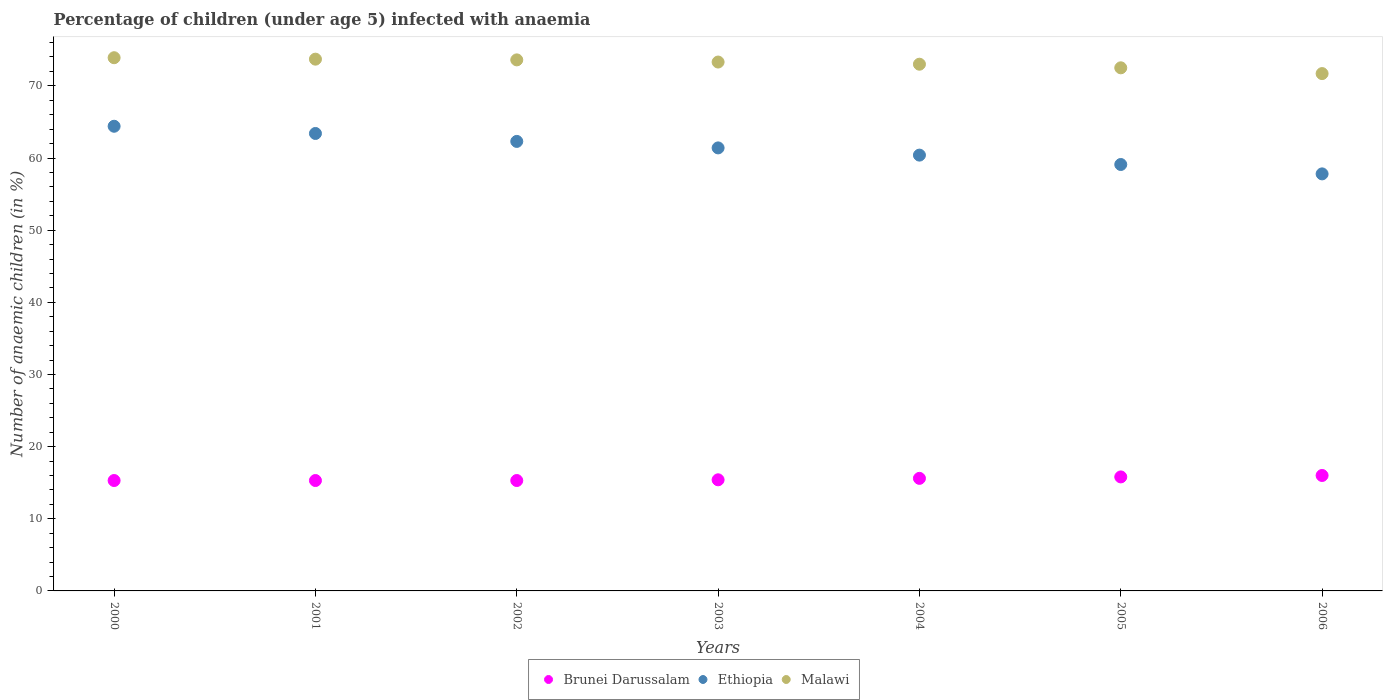What is the percentage of children infected with anaemia in in Malawi in 2003?
Offer a terse response. 73.3. Across all years, what is the maximum percentage of children infected with anaemia in in Ethiopia?
Provide a succinct answer. 64.4. Across all years, what is the minimum percentage of children infected with anaemia in in Malawi?
Your answer should be compact. 71.7. What is the total percentage of children infected with anaemia in in Brunei Darussalam in the graph?
Your answer should be compact. 108.7. What is the difference between the percentage of children infected with anaemia in in Brunei Darussalam in 2001 and that in 2005?
Offer a terse response. -0.5. What is the difference between the percentage of children infected with anaemia in in Ethiopia in 2002 and the percentage of children infected with anaemia in in Malawi in 2005?
Ensure brevity in your answer.  -10.2. What is the average percentage of children infected with anaemia in in Ethiopia per year?
Offer a very short reply. 61.26. In the year 2005, what is the difference between the percentage of children infected with anaemia in in Malawi and percentage of children infected with anaemia in in Ethiopia?
Make the answer very short. 13.4. In how many years, is the percentage of children infected with anaemia in in Ethiopia greater than 66 %?
Provide a succinct answer. 0. What is the ratio of the percentage of children infected with anaemia in in Brunei Darussalam in 2005 to that in 2006?
Your response must be concise. 0.99. Is the percentage of children infected with anaemia in in Ethiopia in 2002 less than that in 2004?
Your answer should be compact. No. What is the difference between the highest and the second highest percentage of children infected with anaemia in in Brunei Darussalam?
Your answer should be compact. 0.2. What is the difference between the highest and the lowest percentage of children infected with anaemia in in Malawi?
Ensure brevity in your answer.  2.2. In how many years, is the percentage of children infected with anaemia in in Brunei Darussalam greater than the average percentage of children infected with anaemia in in Brunei Darussalam taken over all years?
Keep it short and to the point. 3. Is the sum of the percentage of children infected with anaemia in in Malawi in 2003 and 2005 greater than the maximum percentage of children infected with anaemia in in Brunei Darussalam across all years?
Provide a succinct answer. Yes. What is the difference between two consecutive major ticks on the Y-axis?
Provide a succinct answer. 10. Does the graph contain grids?
Offer a very short reply. No. How many legend labels are there?
Make the answer very short. 3. What is the title of the graph?
Give a very brief answer. Percentage of children (under age 5) infected with anaemia. Does "Thailand" appear as one of the legend labels in the graph?
Offer a terse response. No. What is the label or title of the Y-axis?
Offer a terse response. Number of anaemic children (in %). What is the Number of anaemic children (in %) of Brunei Darussalam in 2000?
Ensure brevity in your answer.  15.3. What is the Number of anaemic children (in %) of Ethiopia in 2000?
Ensure brevity in your answer.  64.4. What is the Number of anaemic children (in %) of Malawi in 2000?
Your response must be concise. 73.9. What is the Number of anaemic children (in %) in Ethiopia in 2001?
Your answer should be very brief. 63.4. What is the Number of anaemic children (in %) of Malawi in 2001?
Offer a very short reply. 73.7. What is the Number of anaemic children (in %) of Ethiopia in 2002?
Offer a very short reply. 62.3. What is the Number of anaemic children (in %) of Malawi in 2002?
Keep it short and to the point. 73.6. What is the Number of anaemic children (in %) in Brunei Darussalam in 2003?
Provide a succinct answer. 15.4. What is the Number of anaemic children (in %) in Ethiopia in 2003?
Make the answer very short. 61.4. What is the Number of anaemic children (in %) of Malawi in 2003?
Your answer should be very brief. 73.3. What is the Number of anaemic children (in %) in Ethiopia in 2004?
Offer a terse response. 60.4. What is the Number of anaemic children (in %) of Ethiopia in 2005?
Keep it short and to the point. 59.1. What is the Number of anaemic children (in %) of Malawi in 2005?
Your answer should be compact. 72.5. What is the Number of anaemic children (in %) of Brunei Darussalam in 2006?
Your answer should be very brief. 16. What is the Number of anaemic children (in %) of Ethiopia in 2006?
Provide a succinct answer. 57.8. What is the Number of anaemic children (in %) of Malawi in 2006?
Provide a short and direct response. 71.7. Across all years, what is the maximum Number of anaemic children (in %) in Brunei Darussalam?
Keep it short and to the point. 16. Across all years, what is the maximum Number of anaemic children (in %) in Ethiopia?
Keep it short and to the point. 64.4. Across all years, what is the maximum Number of anaemic children (in %) of Malawi?
Keep it short and to the point. 73.9. Across all years, what is the minimum Number of anaemic children (in %) in Ethiopia?
Provide a short and direct response. 57.8. Across all years, what is the minimum Number of anaemic children (in %) of Malawi?
Keep it short and to the point. 71.7. What is the total Number of anaemic children (in %) of Brunei Darussalam in the graph?
Keep it short and to the point. 108.7. What is the total Number of anaemic children (in %) of Ethiopia in the graph?
Offer a terse response. 428.8. What is the total Number of anaemic children (in %) in Malawi in the graph?
Keep it short and to the point. 511.7. What is the difference between the Number of anaemic children (in %) in Ethiopia in 2000 and that in 2001?
Give a very brief answer. 1. What is the difference between the Number of anaemic children (in %) of Malawi in 2000 and that in 2002?
Your response must be concise. 0.3. What is the difference between the Number of anaemic children (in %) in Brunei Darussalam in 2000 and that in 2003?
Make the answer very short. -0.1. What is the difference between the Number of anaemic children (in %) of Malawi in 2000 and that in 2003?
Your answer should be compact. 0.6. What is the difference between the Number of anaemic children (in %) in Brunei Darussalam in 2000 and that in 2004?
Offer a terse response. -0.3. What is the difference between the Number of anaemic children (in %) in Ethiopia in 2000 and that in 2004?
Your answer should be very brief. 4. What is the difference between the Number of anaemic children (in %) of Malawi in 2000 and that in 2004?
Offer a very short reply. 0.9. What is the difference between the Number of anaemic children (in %) in Brunei Darussalam in 2000 and that in 2005?
Ensure brevity in your answer.  -0.5. What is the difference between the Number of anaemic children (in %) in Malawi in 2000 and that in 2005?
Provide a succinct answer. 1.4. What is the difference between the Number of anaemic children (in %) of Brunei Darussalam in 2000 and that in 2006?
Provide a short and direct response. -0.7. What is the difference between the Number of anaemic children (in %) of Ethiopia in 2000 and that in 2006?
Your answer should be compact. 6.6. What is the difference between the Number of anaemic children (in %) in Malawi in 2000 and that in 2006?
Keep it short and to the point. 2.2. What is the difference between the Number of anaemic children (in %) of Brunei Darussalam in 2001 and that in 2002?
Make the answer very short. 0. What is the difference between the Number of anaemic children (in %) of Brunei Darussalam in 2001 and that in 2003?
Ensure brevity in your answer.  -0.1. What is the difference between the Number of anaemic children (in %) in Malawi in 2001 and that in 2004?
Keep it short and to the point. 0.7. What is the difference between the Number of anaemic children (in %) of Brunei Darussalam in 2001 and that in 2005?
Make the answer very short. -0.5. What is the difference between the Number of anaemic children (in %) in Ethiopia in 2001 and that in 2005?
Your response must be concise. 4.3. What is the difference between the Number of anaemic children (in %) in Brunei Darussalam in 2001 and that in 2006?
Keep it short and to the point. -0.7. What is the difference between the Number of anaemic children (in %) in Ethiopia in 2001 and that in 2006?
Keep it short and to the point. 5.6. What is the difference between the Number of anaemic children (in %) of Brunei Darussalam in 2002 and that in 2003?
Make the answer very short. -0.1. What is the difference between the Number of anaemic children (in %) in Ethiopia in 2002 and that in 2003?
Give a very brief answer. 0.9. What is the difference between the Number of anaemic children (in %) in Ethiopia in 2002 and that in 2004?
Ensure brevity in your answer.  1.9. What is the difference between the Number of anaemic children (in %) of Ethiopia in 2003 and that in 2004?
Make the answer very short. 1. What is the difference between the Number of anaemic children (in %) in Malawi in 2003 and that in 2004?
Give a very brief answer. 0.3. What is the difference between the Number of anaemic children (in %) in Brunei Darussalam in 2003 and that in 2005?
Provide a succinct answer. -0.4. What is the difference between the Number of anaemic children (in %) of Ethiopia in 2003 and that in 2005?
Make the answer very short. 2.3. What is the difference between the Number of anaemic children (in %) in Brunei Darussalam in 2003 and that in 2006?
Keep it short and to the point. -0.6. What is the difference between the Number of anaemic children (in %) of Malawi in 2003 and that in 2006?
Your answer should be compact. 1.6. What is the difference between the Number of anaemic children (in %) in Ethiopia in 2004 and that in 2005?
Offer a terse response. 1.3. What is the difference between the Number of anaemic children (in %) of Malawi in 2004 and that in 2005?
Ensure brevity in your answer.  0.5. What is the difference between the Number of anaemic children (in %) of Malawi in 2004 and that in 2006?
Your response must be concise. 1.3. What is the difference between the Number of anaemic children (in %) in Brunei Darussalam in 2005 and that in 2006?
Offer a very short reply. -0.2. What is the difference between the Number of anaemic children (in %) in Ethiopia in 2005 and that in 2006?
Your response must be concise. 1.3. What is the difference between the Number of anaemic children (in %) of Malawi in 2005 and that in 2006?
Your response must be concise. 0.8. What is the difference between the Number of anaemic children (in %) of Brunei Darussalam in 2000 and the Number of anaemic children (in %) of Ethiopia in 2001?
Your answer should be very brief. -48.1. What is the difference between the Number of anaemic children (in %) of Brunei Darussalam in 2000 and the Number of anaemic children (in %) of Malawi in 2001?
Your answer should be very brief. -58.4. What is the difference between the Number of anaemic children (in %) of Brunei Darussalam in 2000 and the Number of anaemic children (in %) of Ethiopia in 2002?
Your answer should be very brief. -47. What is the difference between the Number of anaemic children (in %) of Brunei Darussalam in 2000 and the Number of anaemic children (in %) of Malawi in 2002?
Your answer should be very brief. -58.3. What is the difference between the Number of anaemic children (in %) of Ethiopia in 2000 and the Number of anaemic children (in %) of Malawi in 2002?
Your response must be concise. -9.2. What is the difference between the Number of anaemic children (in %) in Brunei Darussalam in 2000 and the Number of anaemic children (in %) in Ethiopia in 2003?
Provide a short and direct response. -46.1. What is the difference between the Number of anaemic children (in %) in Brunei Darussalam in 2000 and the Number of anaemic children (in %) in Malawi in 2003?
Your answer should be compact. -58. What is the difference between the Number of anaemic children (in %) of Ethiopia in 2000 and the Number of anaemic children (in %) of Malawi in 2003?
Provide a succinct answer. -8.9. What is the difference between the Number of anaemic children (in %) in Brunei Darussalam in 2000 and the Number of anaemic children (in %) in Ethiopia in 2004?
Provide a short and direct response. -45.1. What is the difference between the Number of anaemic children (in %) of Brunei Darussalam in 2000 and the Number of anaemic children (in %) of Malawi in 2004?
Offer a terse response. -57.7. What is the difference between the Number of anaemic children (in %) of Ethiopia in 2000 and the Number of anaemic children (in %) of Malawi in 2004?
Your answer should be compact. -8.6. What is the difference between the Number of anaemic children (in %) of Brunei Darussalam in 2000 and the Number of anaemic children (in %) of Ethiopia in 2005?
Your answer should be very brief. -43.8. What is the difference between the Number of anaemic children (in %) of Brunei Darussalam in 2000 and the Number of anaemic children (in %) of Malawi in 2005?
Provide a succinct answer. -57.2. What is the difference between the Number of anaemic children (in %) of Brunei Darussalam in 2000 and the Number of anaemic children (in %) of Ethiopia in 2006?
Provide a short and direct response. -42.5. What is the difference between the Number of anaemic children (in %) in Brunei Darussalam in 2000 and the Number of anaemic children (in %) in Malawi in 2006?
Your answer should be compact. -56.4. What is the difference between the Number of anaemic children (in %) of Ethiopia in 2000 and the Number of anaemic children (in %) of Malawi in 2006?
Keep it short and to the point. -7.3. What is the difference between the Number of anaemic children (in %) in Brunei Darussalam in 2001 and the Number of anaemic children (in %) in Ethiopia in 2002?
Ensure brevity in your answer.  -47. What is the difference between the Number of anaemic children (in %) of Brunei Darussalam in 2001 and the Number of anaemic children (in %) of Malawi in 2002?
Ensure brevity in your answer.  -58.3. What is the difference between the Number of anaemic children (in %) of Ethiopia in 2001 and the Number of anaemic children (in %) of Malawi in 2002?
Keep it short and to the point. -10.2. What is the difference between the Number of anaemic children (in %) of Brunei Darussalam in 2001 and the Number of anaemic children (in %) of Ethiopia in 2003?
Keep it short and to the point. -46.1. What is the difference between the Number of anaemic children (in %) in Brunei Darussalam in 2001 and the Number of anaemic children (in %) in Malawi in 2003?
Provide a succinct answer. -58. What is the difference between the Number of anaemic children (in %) of Brunei Darussalam in 2001 and the Number of anaemic children (in %) of Ethiopia in 2004?
Your answer should be very brief. -45.1. What is the difference between the Number of anaemic children (in %) in Brunei Darussalam in 2001 and the Number of anaemic children (in %) in Malawi in 2004?
Provide a short and direct response. -57.7. What is the difference between the Number of anaemic children (in %) of Ethiopia in 2001 and the Number of anaemic children (in %) of Malawi in 2004?
Provide a succinct answer. -9.6. What is the difference between the Number of anaemic children (in %) of Brunei Darussalam in 2001 and the Number of anaemic children (in %) of Ethiopia in 2005?
Make the answer very short. -43.8. What is the difference between the Number of anaemic children (in %) in Brunei Darussalam in 2001 and the Number of anaemic children (in %) in Malawi in 2005?
Ensure brevity in your answer.  -57.2. What is the difference between the Number of anaemic children (in %) in Ethiopia in 2001 and the Number of anaemic children (in %) in Malawi in 2005?
Offer a very short reply. -9.1. What is the difference between the Number of anaemic children (in %) of Brunei Darussalam in 2001 and the Number of anaemic children (in %) of Ethiopia in 2006?
Your answer should be very brief. -42.5. What is the difference between the Number of anaemic children (in %) of Brunei Darussalam in 2001 and the Number of anaemic children (in %) of Malawi in 2006?
Make the answer very short. -56.4. What is the difference between the Number of anaemic children (in %) in Brunei Darussalam in 2002 and the Number of anaemic children (in %) in Ethiopia in 2003?
Your response must be concise. -46.1. What is the difference between the Number of anaemic children (in %) in Brunei Darussalam in 2002 and the Number of anaemic children (in %) in Malawi in 2003?
Your answer should be compact. -58. What is the difference between the Number of anaemic children (in %) of Brunei Darussalam in 2002 and the Number of anaemic children (in %) of Ethiopia in 2004?
Make the answer very short. -45.1. What is the difference between the Number of anaemic children (in %) of Brunei Darussalam in 2002 and the Number of anaemic children (in %) of Malawi in 2004?
Offer a terse response. -57.7. What is the difference between the Number of anaemic children (in %) in Ethiopia in 2002 and the Number of anaemic children (in %) in Malawi in 2004?
Your answer should be very brief. -10.7. What is the difference between the Number of anaemic children (in %) in Brunei Darussalam in 2002 and the Number of anaemic children (in %) in Ethiopia in 2005?
Ensure brevity in your answer.  -43.8. What is the difference between the Number of anaemic children (in %) of Brunei Darussalam in 2002 and the Number of anaemic children (in %) of Malawi in 2005?
Ensure brevity in your answer.  -57.2. What is the difference between the Number of anaemic children (in %) in Brunei Darussalam in 2002 and the Number of anaemic children (in %) in Ethiopia in 2006?
Provide a succinct answer. -42.5. What is the difference between the Number of anaemic children (in %) in Brunei Darussalam in 2002 and the Number of anaemic children (in %) in Malawi in 2006?
Provide a short and direct response. -56.4. What is the difference between the Number of anaemic children (in %) in Ethiopia in 2002 and the Number of anaemic children (in %) in Malawi in 2006?
Your answer should be very brief. -9.4. What is the difference between the Number of anaemic children (in %) in Brunei Darussalam in 2003 and the Number of anaemic children (in %) in Ethiopia in 2004?
Your answer should be very brief. -45. What is the difference between the Number of anaemic children (in %) in Brunei Darussalam in 2003 and the Number of anaemic children (in %) in Malawi in 2004?
Your answer should be compact. -57.6. What is the difference between the Number of anaemic children (in %) in Brunei Darussalam in 2003 and the Number of anaemic children (in %) in Ethiopia in 2005?
Provide a short and direct response. -43.7. What is the difference between the Number of anaemic children (in %) in Brunei Darussalam in 2003 and the Number of anaemic children (in %) in Malawi in 2005?
Your answer should be compact. -57.1. What is the difference between the Number of anaemic children (in %) of Brunei Darussalam in 2003 and the Number of anaemic children (in %) of Ethiopia in 2006?
Offer a very short reply. -42.4. What is the difference between the Number of anaemic children (in %) of Brunei Darussalam in 2003 and the Number of anaemic children (in %) of Malawi in 2006?
Your answer should be compact. -56.3. What is the difference between the Number of anaemic children (in %) of Brunei Darussalam in 2004 and the Number of anaemic children (in %) of Ethiopia in 2005?
Your response must be concise. -43.5. What is the difference between the Number of anaemic children (in %) in Brunei Darussalam in 2004 and the Number of anaemic children (in %) in Malawi in 2005?
Provide a succinct answer. -56.9. What is the difference between the Number of anaemic children (in %) in Brunei Darussalam in 2004 and the Number of anaemic children (in %) in Ethiopia in 2006?
Give a very brief answer. -42.2. What is the difference between the Number of anaemic children (in %) in Brunei Darussalam in 2004 and the Number of anaemic children (in %) in Malawi in 2006?
Keep it short and to the point. -56.1. What is the difference between the Number of anaemic children (in %) in Ethiopia in 2004 and the Number of anaemic children (in %) in Malawi in 2006?
Your answer should be very brief. -11.3. What is the difference between the Number of anaemic children (in %) in Brunei Darussalam in 2005 and the Number of anaemic children (in %) in Ethiopia in 2006?
Ensure brevity in your answer.  -42. What is the difference between the Number of anaemic children (in %) of Brunei Darussalam in 2005 and the Number of anaemic children (in %) of Malawi in 2006?
Ensure brevity in your answer.  -55.9. What is the difference between the Number of anaemic children (in %) of Ethiopia in 2005 and the Number of anaemic children (in %) of Malawi in 2006?
Make the answer very short. -12.6. What is the average Number of anaemic children (in %) of Brunei Darussalam per year?
Provide a succinct answer. 15.53. What is the average Number of anaemic children (in %) of Ethiopia per year?
Provide a succinct answer. 61.26. What is the average Number of anaemic children (in %) of Malawi per year?
Your answer should be very brief. 73.1. In the year 2000, what is the difference between the Number of anaemic children (in %) of Brunei Darussalam and Number of anaemic children (in %) of Ethiopia?
Keep it short and to the point. -49.1. In the year 2000, what is the difference between the Number of anaemic children (in %) of Brunei Darussalam and Number of anaemic children (in %) of Malawi?
Your answer should be very brief. -58.6. In the year 2001, what is the difference between the Number of anaemic children (in %) of Brunei Darussalam and Number of anaemic children (in %) of Ethiopia?
Provide a succinct answer. -48.1. In the year 2001, what is the difference between the Number of anaemic children (in %) in Brunei Darussalam and Number of anaemic children (in %) in Malawi?
Your response must be concise. -58.4. In the year 2002, what is the difference between the Number of anaemic children (in %) in Brunei Darussalam and Number of anaemic children (in %) in Ethiopia?
Your answer should be very brief. -47. In the year 2002, what is the difference between the Number of anaemic children (in %) of Brunei Darussalam and Number of anaemic children (in %) of Malawi?
Keep it short and to the point. -58.3. In the year 2002, what is the difference between the Number of anaemic children (in %) in Ethiopia and Number of anaemic children (in %) in Malawi?
Ensure brevity in your answer.  -11.3. In the year 2003, what is the difference between the Number of anaemic children (in %) in Brunei Darussalam and Number of anaemic children (in %) in Ethiopia?
Keep it short and to the point. -46. In the year 2003, what is the difference between the Number of anaemic children (in %) of Brunei Darussalam and Number of anaemic children (in %) of Malawi?
Provide a short and direct response. -57.9. In the year 2004, what is the difference between the Number of anaemic children (in %) in Brunei Darussalam and Number of anaemic children (in %) in Ethiopia?
Offer a very short reply. -44.8. In the year 2004, what is the difference between the Number of anaemic children (in %) in Brunei Darussalam and Number of anaemic children (in %) in Malawi?
Your answer should be very brief. -57.4. In the year 2005, what is the difference between the Number of anaemic children (in %) of Brunei Darussalam and Number of anaemic children (in %) of Ethiopia?
Provide a succinct answer. -43.3. In the year 2005, what is the difference between the Number of anaemic children (in %) in Brunei Darussalam and Number of anaemic children (in %) in Malawi?
Keep it short and to the point. -56.7. In the year 2006, what is the difference between the Number of anaemic children (in %) of Brunei Darussalam and Number of anaemic children (in %) of Ethiopia?
Offer a very short reply. -41.8. In the year 2006, what is the difference between the Number of anaemic children (in %) of Brunei Darussalam and Number of anaemic children (in %) of Malawi?
Provide a succinct answer. -55.7. In the year 2006, what is the difference between the Number of anaemic children (in %) in Ethiopia and Number of anaemic children (in %) in Malawi?
Make the answer very short. -13.9. What is the ratio of the Number of anaemic children (in %) in Brunei Darussalam in 2000 to that in 2001?
Offer a very short reply. 1. What is the ratio of the Number of anaemic children (in %) of Ethiopia in 2000 to that in 2001?
Give a very brief answer. 1.02. What is the ratio of the Number of anaemic children (in %) in Ethiopia in 2000 to that in 2002?
Your answer should be very brief. 1.03. What is the ratio of the Number of anaemic children (in %) in Ethiopia in 2000 to that in 2003?
Keep it short and to the point. 1.05. What is the ratio of the Number of anaemic children (in %) of Malawi in 2000 to that in 2003?
Give a very brief answer. 1.01. What is the ratio of the Number of anaemic children (in %) in Brunei Darussalam in 2000 to that in 2004?
Your response must be concise. 0.98. What is the ratio of the Number of anaemic children (in %) of Ethiopia in 2000 to that in 2004?
Your answer should be compact. 1.07. What is the ratio of the Number of anaemic children (in %) of Malawi in 2000 to that in 2004?
Keep it short and to the point. 1.01. What is the ratio of the Number of anaemic children (in %) of Brunei Darussalam in 2000 to that in 2005?
Offer a terse response. 0.97. What is the ratio of the Number of anaemic children (in %) in Ethiopia in 2000 to that in 2005?
Provide a short and direct response. 1.09. What is the ratio of the Number of anaemic children (in %) in Malawi in 2000 to that in 2005?
Your answer should be very brief. 1.02. What is the ratio of the Number of anaemic children (in %) of Brunei Darussalam in 2000 to that in 2006?
Your answer should be compact. 0.96. What is the ratio of the Number of anaemic children (in %) in Ethiopia in 2000 to that in 2006?
Your response must be concise. 1.11. What is the ratio of the Number of anaemic children (in %) of Malawi in 2000 to that in 2006?
Make the answer very short. 1.03. What is the ratio of the Number of anaemic children (in %) of Brunei Darussalam in 2001 to that in 2002?
Provide a short and direct response. 1. What is the ratio of the Number of anaemic children (in %) of Ethiopia in 2001 to that in 2002?
Provide a short and direct response. 1.02. What is the ratio of the Number of anaemic children (in %) in Malawi in 2001 to that in 2002?
Offer a very short reply. 1. What is the ratio of the Number of anaemic children (in %) in Brunei Darussalam in 2001 to that in 2003?
Give a very brief answer. 0.99. What is the ratio of the Number of anaemic children (in %) of Ethiopia in 2001 to that in 2003?
Keep it short and to the point. 1.03. What is the ratio of the Number of anaemic children (in %) in Malawi in 2001 to that in 2003?
Provide a short and direct response. 1.01. What is the ratio of the Number of anaemic children (in %) in Brunei Darussalam in 2001 to that in 2004?
Give a very brief answer. 0.98. What is the ratio of the Number of anaemic children (in %) in Ethiopia in 2001 to that in 2004?
Give a very brief answer. 1.05. What is the ratio of the Number of anaemic children (in %) of Malawi in 2001 to that in 2004?
Your answer should be compact. 1.01. What is the ratio of the Number of anaemic children (in %) in Brunei Darussalam in 2001 to that in 2005?
Ensure brevity in your answer.  0.97. What is the ratio of the Number of anaemic children (in %) in Ethiopia in 2001 to that in 2005?
Provide a succinct answer. 1.07. What is the ratio of the Number of anaemic children (in %) of Malawi in 2001 to that in 2005?
Provide a succinct answer. 1.02. What is the ratio of the Number of anaemic children (in %) of Brunei Darussalam in 2001 to that in 2006?
Provide a succinct answer. 0.96. What is the ratio of the Number of anaemic children (in %) in Ethiopia in 2001 to that in 2006?
Provide a succinct answer. 1.1. What is the ratio of the Number of anaemic children (in %) in Malawi in 2001 to that in 2006?
Your answer should be compact. 1.03. What is the ratio of the Number of anaemic children (in %) in Brunei Darussalam in 2002 to that in 2003?
Your response must be concise. 0.99. What is the ratio of the Number of anaemic children (in %) of Ethiopia in 2002 to that in 2003?
Offer a very short reply. 1.01. What is the ratio of the Number of anaemic children (in %) of Malawi in 2002 to that in 2003?
Your answer should be compact. 1. What is the ratio of the Number of anaemic children (in %) of Brunei Darussalam in 2002 to that in 2004?
Offer a very short reply. 0.98. What is the ratio of the Number of anaemic children (in %) in Ethiopia in 2002 to that in 2004?
Offer a very short reply. 1.03. What is the ratio of the Number of anaemic children (in %) of Malawi in 2002 to that in 2004?
Your answer should be compact. 1.01. What is the ratio of the Number of anaemic children (in %) of Brunei Darussalam in 2002 to that in 2005?
Your response must be concise. 0.97. What is the ratio of the Number of anaemic children (in %) of Ethiopia in 2002 to that in 2005?
Your answer should be compact. 1.05. What is the ratio of the Number of anaemic children (in %) in Malawi in 2002 to that in 2005?
Your answer should be compact. 1.02. What is the ratio of the Number of anaemic children (in %) in Brunei Darussalam in 2002 to that in 2006?
Your response must be concise. 0.96. What is the ratio of the Number of anaemic children (in %) in Ethiopia in 2002 to that in 2006?
Make the answer very short. 1.08. What is the ratio of the Number of anaemic children (in %) in Malawi in 2002 to that in 2006?
Your response must be concise. 1.03. What is the ratio of the Number of anaemic children (in %) in Brunei Darussalam in 2003 to that in 2004?
Provide a succinct answer. 0.99. What is the ratio of the Number of anaemic children (in %) of Ethiopia in 2003 to that in 2004?
Provide a short and direct response. 1.02. What is the ratio of the Number of anaemic children (in %) of Brunei Darussalam in 2003 to that in 2005?
Offer a very short reply. 0.97. What is the ratio of the Number of anaemic children (in %) of Ethiopia in 2003 to that in 2005?
Keep it short and to the point. 1.04. What is the ratio of the Number of anaemic children (in %) of Brunei Darussalam in 2003 to that in 2006?
Keep it short and to the point. 0.96. What is the ratio of the Number of anaemic children (in %) in Ethiopia in 2003 to that in 2006?
Provide a succinct answer. 1.06. What is the ratio of the Number of anaemic children (in %) in Malawi in 2003 to that in 2006?
Give a very brief answer. 1.02. What is the ratio of the Number of anaemic children (in %) in Brunei Darussalam in 2004 to that in 2005?
Your answer should be very brief. 0.99. What is the ratio of the Number of anaemic children (in %) of Ethiopia in 2004 to that in 2005?
Your response must be concise. 1.02. What is the ratio of the Number of anaemic children (in %) of Ethiopia in 2004 to that in 2006?
Provide a succinct answer. 1.04. What is the ratio of the Number of anaemic children (in %) in Malawi in 2004 to that in 2006?
Your answer should be very brief. 1.02. What is the ratio of the Number of anaemic children (in %) of Brunei Darussalam in 2005 to that in 2006?
Provide a succinct answer. 0.99. What is the ratio of the Number of anaemic children (in %) in Ethiopia in 2005 to that in 2006?
Your response must be concise. 1.02. What is the ratio of the Number of anaemic children (in %) in Malawi in 2005 to that in 2006?
Make the answer very short. 1.01. What is the difference between the highest and the second highest Number of anaemic children (in %) of Ethiopia?
Offer a terse response. 1. What is the difference between the highest and the second highest Number of anaemic children (in %) of Malawi?
Your answer should be very brief. 0.2. What is the difference between the highest and the lowest Number of anaemic children (in %) of Brunei Darussalam?
Your answer should be compact. 0.7. What is the difference between the highest and the lowest Number of anaemic children (in %) of Ethiopia?
Provide a succinct answer. 6.6. What is the difference between the highest and the lowest Number of anaemic children (in %) in Malawi?
Ensure brevity in your answer.  2.2. 